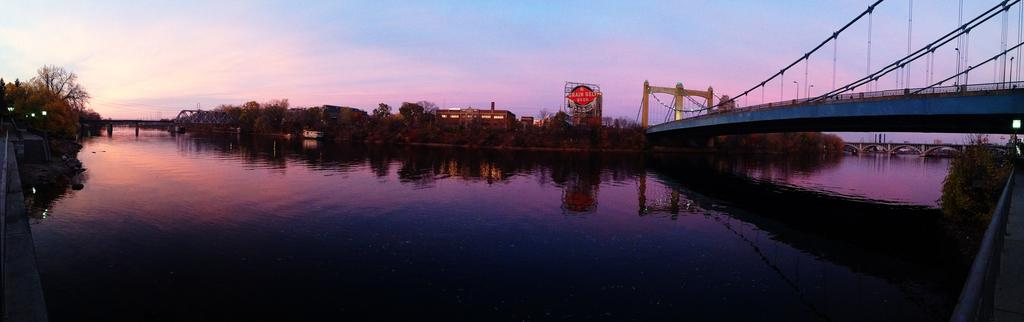What is the main subject of the image? The main subject of the image is a boat on the water. What other structures or objects can be seen in the image? There are bridges, buildings, trees, a name board, and some objects visible in the image. What is the background of the image? The sky is visible in the background of the image. What type of apple can be seen hanging from the hook in the image? There is no apple or hook present in the image. 